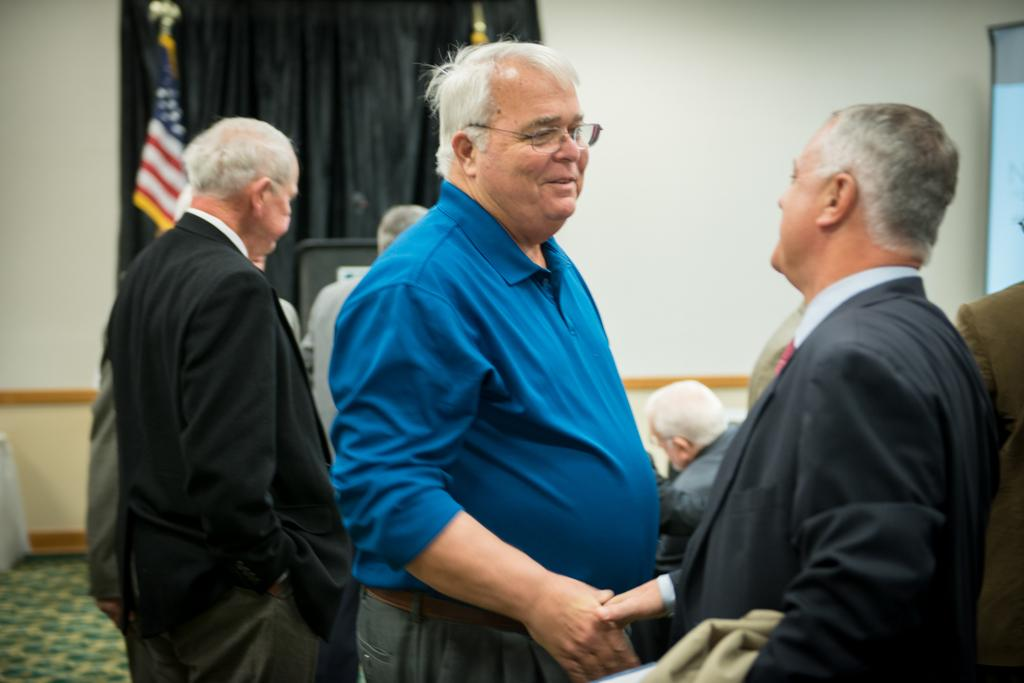How many men are in the room in the image? There is a group of men in the room in the image. What are two men doing in the front of the image? Two men are greeting each other in the front of the image. What can be seen in the background of the image? There is a black curtain, a flag, and a wall in the background of the image. What time is displayed on the clock in the image? There is no clock present in the image. What type of boot is being worn by the man in the image? There is no boot visible in the image; the men are wearing clothing that does not include boots. 